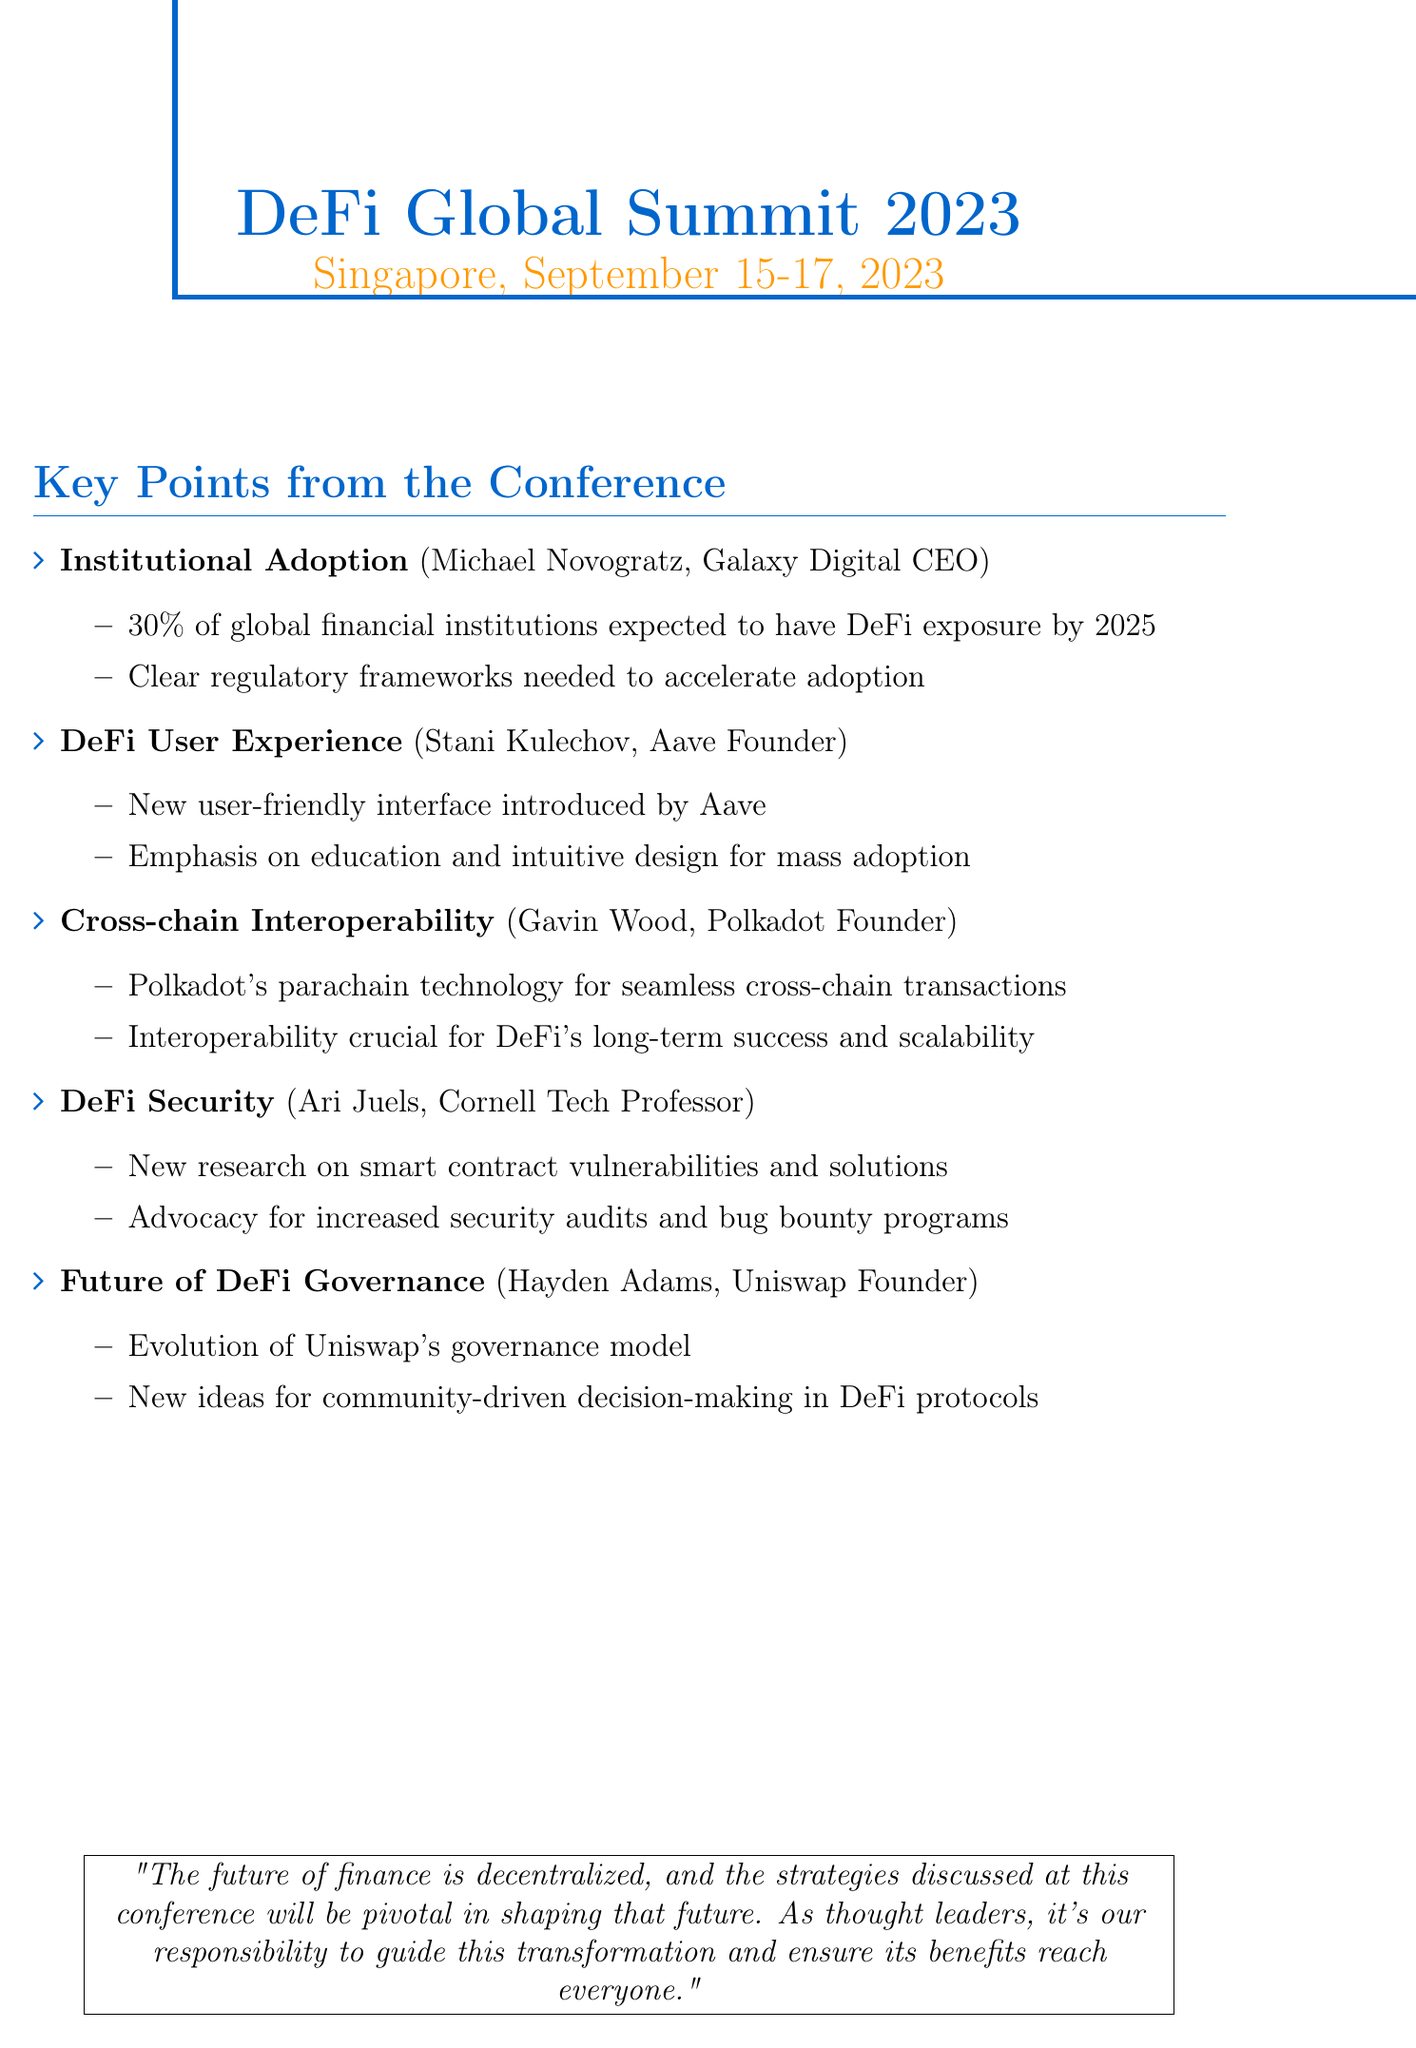What is the location of the DeFi Global Summit 2023? The location is specified as Singapore in the conference details.
Answer: Singapore Who is the CEO of Galaxy Digital? The document identifies Michael Novogratz as the CEO of Galaxy Digital.
Answer: Michael Novogratz What percentage of global financial institutions is predicted to have DeFi exposure by 2025? This prediction is highlighted as 30% in the key points section by Michael Novogratz.
Answer: 30% What technology does Gavin Wood showcase for cross-chain transactions? The technology discussed by Gavin Wood is Polkadot's parachain technology.
Answer: Parachain technology Which element is emphasized as crucial for DeFi's long-term success? Interoperability is proposed as crucial for DeFi's long-term success by Gavin Wood.
Answer: Interoperability What is a key focus for Stani Kulechov regarding mass adoption? He stresses the importance of education and intuitive design in driving mass adoption.
Answer: Education and intuitive design What new idea did Hayden Adams propose for DeFi governance? He proposed new ideas for community-driven decision-making in DeFi protocols.
Answer: Community-driven decision-making Who presented research on smart contract vulnerabilities? The presentation on smart contract vulnerabilities was given by Ari Juels from Cornell Tech.
Answer: Ari Juels What quote summarizes the conference's vision for the future of finance? The quote states that "The future of finance is decentralized" and emphasizes responsible guidance for transformation.
Answer: The future of finance is decentralized 